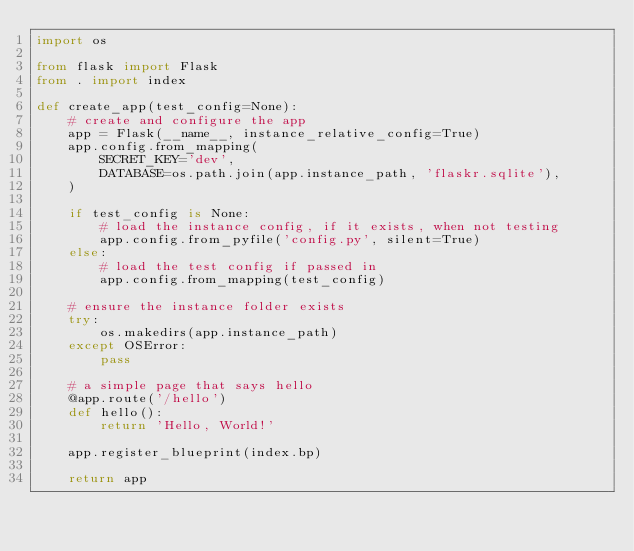Convert code to text. <code><loc_0><loc_0><loc_500><loc_500><_Python_>import os

from flask import Flask
from . import index

def create_app(test_config=None):
    # create and configure the app
    app = Flask(__name__, instance_relative_config=True)
    app.config.from_mapping(
        SECRET_KEY='dev',
        DATABASE=os.path.join(app.instance_path, 'flaskr.sqlite'),
    )

    if test_config is None:
        # load the instance config, if it exists, when not testing
        app.config.from_pyfile('config.py', silent=True)
    else:
        # load the test config if passed in
        app.config.from_mapping(test_config)

    # ensure the instance folder exists
    try:
        os.makedirs(app.instance_path)
    except OSError:
        pass

    # a simple page that says hello
    @app.route('/hello')
    def hello():
        return 'Hello, World!'
    
    app.register_blueprint(index.bp)

    return app</code> 